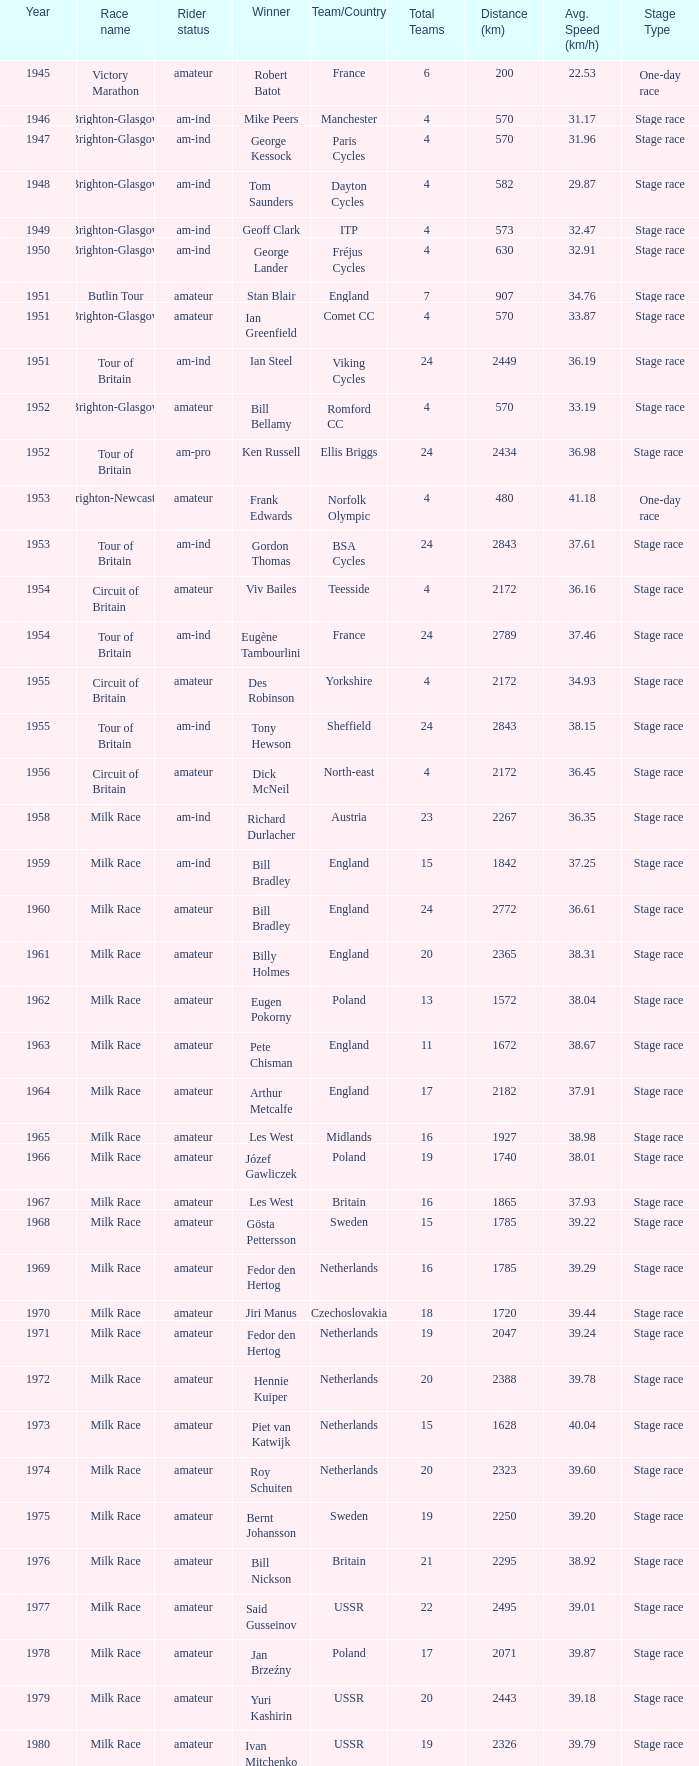Who was the winner in 1973 with an amateur rider status? Piet van Katwijk. 